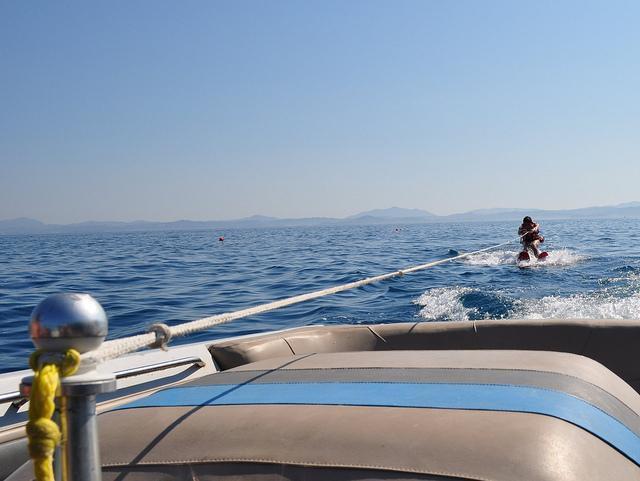How many toilet rolls are reflected in the mirror?
Give a very brief answer. 0. 